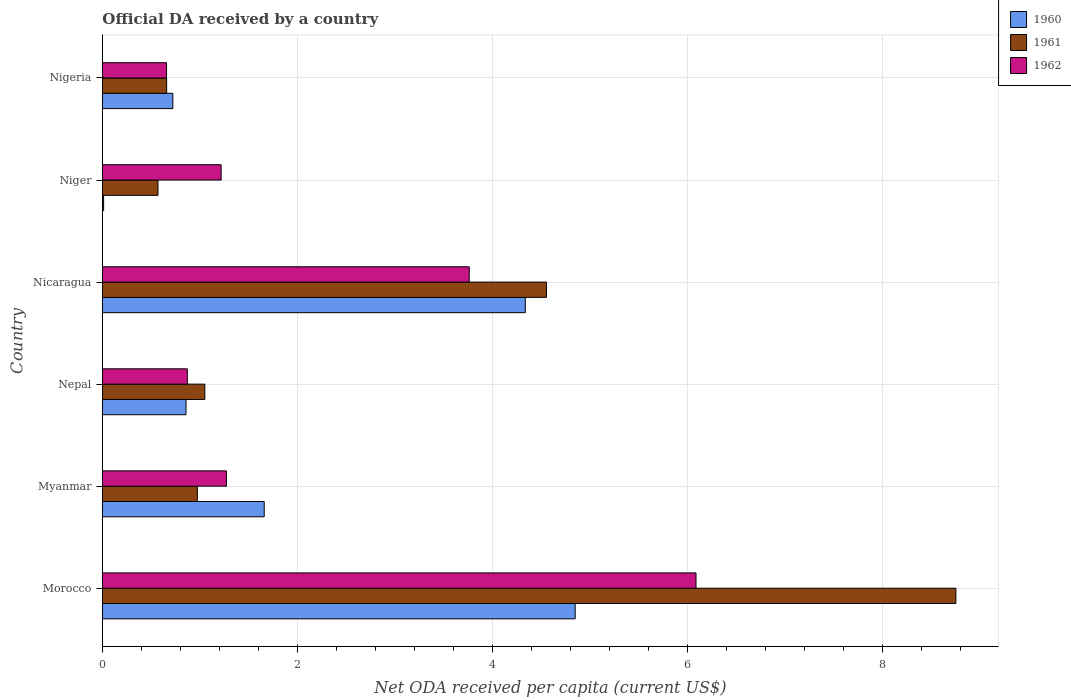How many groups of bars are there?
Keep it short and to the point. 6. What is the label of the 3rd group of bars from the top?
Your response must be concise. Nicaragua. What is the ODA received in in 1961 in Morocco?
Give a very brief answer. 8.76. Across all countries, what is the maximum ODA received in in 1961?
Ensure brevity in your answer.  8.76. Across all countries, what is the minimum ODA received in in 1962?
Give a very brief answer. 0.66. In which country was the ODA received in in 1960 maximum?
Offer a very short reply. Morocco. In which country was the ODA received in in 1960 minimum?
Ensure brevity in your answer.  Niger. What is the total ODA received in in 1961 in the graph?
Make the answer very short. 16.57. What is the difference between the ODA received in in 1962 in Morocco and that in Nicaragua?
Ensure brevity in your answer.  2.33. What is the difference between the ODA received in in 1960 in Myanmar and the ODA received in in 1962 in Nicaragua?
Your response must be concise. -2.1. What is the average ODA received in in 1960 per country?
Ensure brevity in your answer.  2.07. What is the difference between the ODA received in in 1961 and ODA received in in 1962 in Nigeria?
Your answer should be compact. 0. In how many countries, is the ODA received in in 1962 greater than 4 US$?
Keep it short and to the point. 1. What is the ratio of the ODA received in in 1960 in Nepal to that in Nicaragua?
Your answer should be very brief. 0.2. Is the ODA received in in 1962 in Morocco less than that in Myanmar?
Offer a terse response. No. Is the difference between the ODA received in in 1961 in Morocco and Nigeria greater than the difference between the ODA received in in 1962 in Morocco and Nigeria?
Offer a very short reply. Yes. What is the difference between the highest and the second highest ODA received in in 1961?
Your answer should be very brief. 4.2. What is the difference between the highest and the lowest ODA received in in 1961?
Offer a very short reply. 8.19. Is the sum of the ODA received in in 1961 in Myanmar and Nepal greater than the maximum ODA received in in 1962 across all countries?
Keep it short and to the point. No. Is it the case that in every country, the sum of the ODA received in in 1960 and ODA received in in 1962 is greater than the ODA received in in 1961?
Make the answer very short. Yes. How many bars are there?
Give a very brief answer. 18. How many countries are there in the graph?
Your answer should be compact. 6. What is the difference between two consecutive major ticks on the X-axis?
Provide a short and direct response. 2. Are the values on the major ticks of X-axis written in scientific E-notation?
Give a very brief answer. No. Where does the legend appear in the graph?
Offer a very short reply. Top right. How are the legend labels stacked?
Give a very brief answer. Vertical. What is the title of the graph?
Your response must be concise. Official DA received by a country. Does "1980" appear as one of the legend labels in the graph?
Offer a terse response. No. What is the label or title of the X-axis?
Your answer should be very brief. Net ODA received per capita (current US$). What is the label or title of the Y-axis?
Give a very brief answer. Country. What is the Net ODA received per capita (current US$) of 1960 in Morocco?
Offer a terse response. 4.85. What is the Net ODA received per capita (current US$) of 1961 in Morocco?
Make the answer very short. 8.76. What is the Net ODA received per capita (current US$) in 1962 in Morocco?
Give a very brief answer. 6.09. What is the Net ODA received per capita (current US$) in 1960 in Myanmar?
Give a very brief answer. 1.66. What is the Net ODA received per capita (current US$) in 1961 in Myanmar?
Keep it short and to the point. 0.97. What is the Net ODA received per capita (current US$) in 1962 in Myanmar?
Your response must be concise. 1.27. What is the Net ODA received per capita (current US$) of 1960 in Nepal?
Give a very brief answer. 0.86. What is the Net ODA received per capita (current US$) of 1961 in Nepal?
Give a very brief answer. 1.05. What is the Net ODA received per capita (current US$) of 1962 in Nepal?
Give a very brief answer. 0.87. What is the Net ODA received per capita (current US$) of 1960 in Nicaragua?
Offer a very short reply. 4.34. What is the Net ODA received per capita (current US$) of 1961 in Nicaragua?
Your response must be concise. 4.56. What is the Net ODA received per capita (current US$) of 1962 in Nicaragua?
Make the answer very short. 3.76. What is the Net ODA received per capita (current US$) in 1960 in Niger?
Your response must be concise. 0.01. What is the Net ODA received per capita (current US$) in 1961 in Niger?
Provide a succinct answer. 0.57. What is the Net ODA received per capita (current US$) in 1962 in Niger?
Ensure brevity in your answer.  1.22. What is the Net ODA received per capita (current US$) in 1960 in Nigeria?
Make the answer very short. 0.72. What is the Net ODA received per capita (current US$) of 1961 in Nigeria?
Your answer should be very brief. 0.66. What is the Net ODA received per capita (current US$) of 1962 in Nigeria?
Make the answer very short. 0.66. Across all countries, what is the maximum Net ODA received per capita (current US$) of 1960?
Your response must be concise. 4.85. Across all countries, what is the maximum Net ODA received per capita (current US$) of 1961?
Your answer should be compact. 8.76. Across all countries, what is the maximum Net ODA received per capita (current US$) of 1962?
Keep it short and to the point. 6.09. Across all countries, what is the minimum Net ODA received per capita (current US$) in 1960?
Keep it short and to the point. 0.01. Across all countries, what is the minimum Net ODA received per capita (current US$) of 1961?
Offer a very short reply. 0.57. Across all countries, what is the minimum Net ODA received per capita (current US$) in 1962?
Give a very brief answer. 0.66. What is the total Net ODA received per capita (current US$) of 1960 in the graph?
Your answer should be very brief. 12.44. What is the total Net ODA received per capita (current US$) in 1961 in the graph?
Ensure brevity in your answer.  16.57. What is the total Net ODA received per capita (current US$) of 1962 in the graph?
Provide a short and direct response. 13.87. What is the difference between the Net ODA received per capita (current US$) of 1960 in Morocco and that in Myanmar?
Keep it short and to the point. 3.19. What is the difference between the Net ODA received per capita (current US$) of 1961 in Morocco and that in Myanmar?
Keep it short and to the point. 7.78. What is the difference between the Net ODA received per capita (current US$) of 1962 in Morocco and that in Myanmar?
Your response must be concise. 4.82. What is the difference between the Net ODA received per capita (current US$) of 1960 in Morocco and that in Nepal?
Keep it short and to the point. 3.99. What is the difference between the Net ODA received per capita (current US$) of 1961 in Morocco and that in Nepal?
Offer a terse response. 7.71. What is the difference between the Net ODA received per capita (current US$) of 1962 in Morocco and that in Nepal?
Your answer should be very brief. 5.22. What is the difference between the Net ODA received per capita (current US$) of 1960 in Morocco and that in Nicaragua?
Offer a terse response. 0.51. What is the difference between the Net ODA received per capita (current US$) of 1961 in Morocco and that in Nicaragua?
Keep it short and to the point. 4.2. What is the difference between the Net ODA received per capita (current US$) in 1962 in Morocco and that in Nicaragua?
Make the answer very short. 2.33. What is the difference between the Net ODA received per capita (current US$) of 1960 in Morocco and that in Niger?
Make the answer very short. 4.84. What is the difference between the Net ODA received per capita (current US$) of 1961 in Morocco and that in Niger?
Offer a terse response. 8.19. What is the difference between the Net ODA received per capita (current US$) in 1962 in Morocco and that in Niger?
Your answer should be very brief. 4.87. What is the difference between the Net ODA received per capita (current US$) in 1960 in Morocco and that in Nigeria?
Ensure brevity in your answer.  4.13. What is the difference between the Net ODA received per capita (current US$) of 1961 in Morocco and that in Nigeria?
Your response must be concise. 8.1. What is the difference between the Net ODA received per capita (current US$) in 1962 in Morocco and that in Nigeria?
Provide a succinct answer. 5.43. What is the difference between the Net ODA received per capita (current US$) in 1960 in Myanmar and that in Nepal?
Ensure brevity in your answer.  0.8. What is the difference between the Net ODA received per capita (current US$) of 1961 in Myanmar and that in Nepal?
Offer a very short reply. -0.08. What is the difference between the Net ODA received per capita (current US$) of 1962 in Myanmar and that in Nepal?
Your response must be concise. 0.4. What is the difference between the Net ODA received per capita (current US$) of 1960 in Myanmar and that in Nicaragua?
Make the answer very short. -2.68. What is the difference between the Net ODA received per capita (current US$) in 1961 in Myanmar and that in Nicaragua?
Offer a very short reply. -3.58. What is the difference between the Net ODA received per capita (current US$) in 1962 in Myanmar and that in Nicaragua?
Ensure brevity in your answer.  -2.49. What is the difference between the Net ODA received per capita (current US$) in 1960 in Myanmar and that in Niger?
Provide a succinct answer. 1.65. What is the difference between the Net ODA received per capita (current US$) of 1961 in Myanmar and that in Niger?
Your answer should be compact. 0.4. What is the difference between the Net ODA received per capita (current US$) in 1962 in Myanmar and that in Niger?
Your answer should be very brief. 0.05. What is the difference between the Net ODA received per capita (current US$) in 1960 in Myanmar and that in Nigeria?
Make the answer very short. 0.94. What is the difference between the Net ODA received per capita (current US$) of 1961 in Myanmar and that in Nigeria?
Offer a very short reply. 0.31. What is the difference between the Net ODA received per capita (current US$) of 1962 in Myanmar and that in Nigeria?
Offer a terse response. 0.61. What is the difference between the Net ODA received per capita (current US$) of 1960 in Nepal and that in Nicaragua?
Make the answer very short. -3.48. What is the difference between the Net ODA received per capita (current US$) of 1961 in Nepal and that in Nicaragua?
Give a very brief answer. -3.51. What is the difference between the Net ODA received per capita (current US$) of 1962 in Nepal and that in Nicaragua?
Offer a very short reply. -2.89. What is the difference between the Net ODA received per capita (current US$) of 1960 in Nepal and that in Niger?
Your answer should be very brief. 0.85. What is the difference between the Net ODA received per capita (current US$) in 1961 in Nepal and that in Niger?
Give a very brief answer. 0.48. What is the difference between the Net ODA received per capita (current US$) of 1962 in Nepal and that in Niger?
Offer a terse response. -0.35. What is the difference between the Net ODA received per capita (current US$) in 1960 in Nepal and that in Nigeria?
Your response must be concise. 0.14. What is the difference between the Net ODA received per capita (current US$) in 1961 in Nepal and that in Nigeria?
Your answer should be compact. 0.39. What is the difference between the Net ODA received per capita (current US$) in 1962 in Nepal and that in Nigeria?
Give a very brief answer. 0.21. What is the difference between the Net ODA received per capita (current US$) in 1960 in Nicaragua and that in Niger?
Keep it short and to the point. 4.33. What is the difference between the Net ODA received per capita (current US$) of 1961 in Nicaragua and that in Niger?
Make the answer very short. 3.99. What is the difference between the Net ODA received per capita (current US$) in 1962 in Nicaragua and that in Niger?
Ensure brevity in your answer.  2.55. What is the difference between the Net ODA received per capita (current US$) of 1960 in Nicaragua and that in Nigeria?
Your answer should be compact. 3.62. What is the difference between the Net ODA received per capita (current US$) in 1961 in Nicaragua and that in Nigeria?
Give a very brief answer. 3.9. What is the difference between the Net ODA received per capita (current US$) of 1962 in Nicaragua and that in Nigeria?
Offer a very short reply. 3.11. What is the difference between the Net ODA received per capita (current US$) in 1960 in Niger and that in Nigeria?
Your answer should be compact. -0.71. What is the difference between the Net ODA received per capita (current US$) in 1961 in Niger and that in Nigeria?
Offer a very short reply. -0.09. What is the difference between the Net ODA received per capita (current US$) in 1962 in Niger and that in Nigeria?
Your answer should be compact. 0.56. What is the difference between the Net ODA received per capita (current US$) of 1960 in Morocco and the Net ODA received per capita (current US$) of 1961 in Myanmar?
Offer a terse response. 3.88. What is the difference between the Net ODA received per capita (current US$) of 1960 in Morocco and the Net ODA received per capita (current US$) of 1962 in Myanmar?
Offer a terse response. 3.58. What is the difference between the Net ODA received per capita (current US$) of 1961 in Morocco and the Net ODA received per capita (current US$) of 1962 in Myanmar?
Offer a very short reply. 7.48. What is the difference between the Net ODA received per capita (current US$) in 1960 in Morocco and the Net ODA received per capita (current US$) in 1961 in Nepal?
Provide a succinct answer. 3.8. What is the difference between the Net ODA received per capita (current US$) in 1960 in Morocco and the Net ODA received per capita (current US$) in 1962 in Nepal?
Offer a very short reply. 3.98. What is the difference between the Net ODA received per capita (current US$) of 1961 in Morocco and the Net ODA received per capita (current US$) of 1962 in Nepal?
Give a very brief answer. 7.89. What is the difference between the Net ODA received per capita (current US$) of 1960 in Morocco and the Net ODA received per capita (current US$) of 1961 in Nicaragua?
Your answer should be very brief. 0.29. What is the difference between the Net ODA received per capita (current US$) of 1960 in Morocco and the Net ODA received per capita (current US$) of 1962 in Nicaragua?
Your answer should be compact. 1.09. What is the difference between the Net ODA received per capita (current US$) of 1961 in Morocco and the Net ODA received per capita (current US$) of 1962 in Nicaragua?
Make the answer very short. 4.99. What is the difference between the Net ODA received per capita (current US$) of 1960 in Morocco and the Net ODA received per capita (current US$) of 1961 in Niger?
Give a very brief answer. 4.28. What is the difference between the Net ODA received per capita (current US$) of 1960 in Morocco and the Net ODA received per capita (current US$) of 1962 in Niger?
Provide a short and direct response. 3.63. What is the difference between the Net ODA received per capita (current US$) of 1961 in Morocco and the Net ODA received per capita (current US$) of 1962 in Niger?
Your answer should be very brief. 7.54. What is the difference between the Net ODA received per capita (current US$) in 1960 in Morocco and the Net ODA received per capita (current US$) in 1961 in Nigeria?
Provide a short and direct response. 4.19. What is the difference between the Net ODA received per capita (current US$) of 1960 in Morocco and the Net ODA received per capita (current US$) of 1962 in Nigeria?
Your response must be concise. 4.19. What is the difference between the Net ODA received per capita (current US$) of 1961 in Morocco and the Net ODA received per capita (current US$) of 1962 in Nigeria?
Your answer should be compact. 8.1. What is the difference between the Net ODA received per capita (current US$) in 1960 in Myanmar and the Net ODA received per capita (current US$) in 1961 in Nepal?
Your answer should be very brief. 0.61. What is the difference between the Net ODA received per capita (current US$) in 1960 in Myanmar and the Net ODA received per capita (current US$) in 1962 in Nepal?
Provide a short and direct response. 0.79. What is the difference between the Net ODA received per capita (current US$) in 1961 in Myanmar and the Net ODA received per capita (current US$) in 1962 in Nepal?
Ensure brevity in your answer.  0.1. What is the difference between the Net ODA received per capita (current US$) of 1960 in Myanmar and the Net ODA received per capita (current US$) of 1961 in Nicaragua?
Your answer should be compact. -2.9. What is the difference between the Net ODA received per capita (current US$) of 1960 in Myanmar and the Net ODA received per capita (current US$) of 1962 in Nicaragua?
Offer a very short reply. -2.1. What is the difference between the Net ODA received per capita (current US$) in 1961 in Myanmar and the Net ODA received per capita (current US$) in 1962 in Nicaragua?
Your answer should be compact. -2.79. What is the difference between the Net ODA received per capita (current US$) in 1960 in Myanmar and the Net ODA received per capita (current US$) in 1961 in Niger?
Give a very brief answer. 1.09. What is the difference between the Net ODA received per capita (current US$) of 1960 in Myanmar and the Net ODA received per capita (current US$) of 1962 in Niger?
Your answer should be very brief. 0.44. What is the difference between the Net ODA received per capita (current US$) in 1961 in Myanmar and the Net ODA received per capita (current US$) in 1962 in Niger?
Offer a terse response. -0.24. What is the difference between the Net ODA received per capita (current US$) of 1961 in Myanmar and the Net ODA received per capita (current US$) of 1962 in Nigeria?
Offer a very short reply. 0.32. What is the difference between the Net ODA received per capita (current US$) in 1960 in Nepal and the Net ODA received per capita (current US$) in 1961 in Nicaragua?
Give a very brief answer. -3.7. What is the difference between the Net ODA received per capita (current US$) in 1960 in Nepal and the Net ODA received per capita (current US$) in 1962 in Nicaragua?
Provide a short and direct response. -2.91. What is the difference between the Net ODA received per capita (current US$) in 1961 in Nepal and the Net ODA received per capita (current US$) in 1962 in Nicaragua?
Ensure brevity in your answer.  -2.71. What is the difference between the Net ODA received per capita (current US$) in 1960 in Nepal and the Net ODA received per capita (current US$) in 1961 in Niger?
Make the answer very short. 0.29. What is the difference between the Net ODA received per capita (current US$) in 1960 in Nepal and the Net ODA received per capita (current US$) in 1962 in Niger?
Keep it short and to the point. -0.36. What is the difference between the Net ODA received per capita (current US$) in 1961 in Nepal and the Net ODA received per capita (current US$) in 1962 in Niger?
Give a very brief answer. -0.17. What is the difference between the Net ODA received per capita (current US$) in 1960 in Nepal and the Net ODA received per capita (current US$) in 1961 in Nigeria?
Give a very brief answer. 0.2. What is the difference between the Net ODA received per capita (current US$) in 1960 in Nepal and the Net ODA received per capita (current US$) in 1962 in Nigeria?
Give a very brief answer. 0.2. What is the difference between the Net ODA received per capita (current US$) of 1961 in Nepal and the Net ODA received per capita (current US$) of 1962 in Nigeria?
Your answer should be compact. 0.39. What is the difference between the Net ODA received per capita (current US$) in 1960 in Nicaragua and the Net ODA received per capita (current US$) in 1961 in Niger?
Offer a terse response. 3.77. What is the difference between the Net ODA received per capita (current US$) of 1960 in Nicaragua and the Net ODA received per capita (current US$) of 1962 in Niger?
Your answer should be very brief. 3.12. What is the difference between the Net ODA received per capita (current US$) of 1961 in Nicaragua and the Net ODA received per capita (current US$) of 1962 in Niger?
Provide a succinct answer. 3.34. What is the difference between the Net ODA received per capita (current US$) in 1960 in Nicaragua and the Net ODA received per capita (current US$) in 1961 in Nigeria?
Keep it short and to the point. 3.68. What is the difference between the Net ODA received per capita (current US$) of 1960 in Nicaragua and the Net ODA received per capita (current US$) of 1962 in Nigeria?
Offer a terse response. 3.68. What is the difference between the Net ODA received per capita (current US$) in 1961 in Nicaragua and the Net ODA received per capita (current US$) in 1962 in Nigeria?
Offer a very short reply. 3.9. What is the difference between the Net ODA received per capita (current US$) in 1960 in Niger and the Net ODA received per capita (current US$) in 1961 in Nigeria?
Ensure brevity in your answer.  -0.65. What is the difference between the Net ODA received per capita (current US$) of 1960 in Niger and the Net ODA received per capita (current US$) of 1962 in Nigeria?
Offer a terse response. -0.65. What is the difference between the Net ODA received per capita (current US$) in 1961 in Niger and the Net ODA received per capita (current US$) in 1962 in Nigeria?
Provide a succinct answer. -0.09. What is the average Net ODA received per capita (current US$) in 1960 per country?
Make the answer very short. 2.07. What is the average Net ODA received per capita (current US$) of 1961 per country?
Your response must be concise. 2.76. What is the average Net ODA received per capita (current US$) in 1962 per country?
Your response must be concise. 2.31. What is the difference between the Net ODA received per capita (current US$) of 1960 and Net ODA received per capita (current US$) of 1961 in Morocco?
Your answer should be very brief. -3.91. What is the difference between the Net ODA received per capita (current US$) in 1960 and Net ODA received per capita (current US$) in 1962 in Morocco?
Provide a short and direct response. -1.24. What is the difference between the Net ODA received per capita (current US$) in 1961 and Net ODA received per capita (current US$) in 1962 in Morocco?
Keep it short and to the point. 2.67. What is the difference between the Net ODA received per capita (current US$) of 1960 and Net ODA received per capita (current US$) of 1961 in Myanmar?
Provide a succinct answer. 0.69. What is the difference between the Net ODA received per capita (current US$) of 1960 and Net ODA received per capita (current US$) of 1962 in Myanmar?
Your response must be concise. 0.39. What is the difference between the Net ODA received per capita (current US$) in 1961 and Net ODA received per capita (current US$) in 1962 in Myanmar?
Provide a succinct answer. -0.3. What is the difference between the Net ODA received per capita (current US$) in 1960 and Net ODA received per capita (current US$) in 1961 in Nepal?
Make the answer very short. -0.19. What is the difference between the Net ODA received per capita (current US$) of 1960 and Net ODA received per capita (current US$) of 1962 in Nepal?
Your answer should be compact. -0.01. What is the difference between the Net ODA received per capita (current US$) of 1961 and Net ODA received per capita (current US$) of 1962 in Nepal?
Give a very brief answer. 0.18. What is the difference between the Net ODA received per capita (current US$) of 1960 and Net ODA received per capita (current US$) of 1961 in Nicaragua?
Your answer should be compact. -0.22. What is the difference between the Net ODA received per capita (current US$) in 1960 and Net ODA received per capita (current US$) in 1962 in Nicaragua?
Make the answer very short. 0.58. What is the difference between the Net ODA received per capita (current US$) in 1961 and Net ODA received per capita (current US$) in 1962 in Nicaragua?
Make the answer very short. 0.79. What is the difference between the Net ODA received per capita (current US$) of 1960 and Net ODA received per capita (current US$) of 1961 in Niger?
Your response must be concise. -0.56. What is the difference between the Net ODA received per capita (current US$) of 1960 and Net ODA received per capita (current US$) of 1962 in Niger?
Your answer should be very brief. -1.21. What is the difference between the Net ODA received per capita (current US$) in 1961 and Net ODA received per capita (current US$) in 1962 in Niger?
Provide a succinct answer. -0.65. What is the difference between the Net ODA received per capita (current US$) in 1960 and Net ODA received per capita (current US$) in 1961 in Nigeria?
Provide a succinct answer. 0.06. What is the difference between the Net ODA received per capita (current US$) in 1960 and Net ODA received per capita (current US$) in 1962 in Nigeria?
Provide a succinct answer. 0.06. What is the difference between the Net ODA received per capita (current US$) of 1961 and Net ODA received per capita (current US$) of 1962 in Nigeria?
Your answer should be very brief. 0. What is the ratio of the Net ODA received per capita (current US$) of 1960 in Morocco to that in Myanmar?
Offer a very short reply. 2.92. What is the ratio of the Net ODA received per capita (current US$) of 1961 in Morocco to that in Myanmar?
Provide a short and direct response. 9. What is the ratio of the Net ODA received per capita (current US$) of 1962 in Morocco to that in Myanmar?
Provide a succinct answer. 4.79. What is the ratio of the Net ODA received per capita (current US$) in 1960 in Morocco to that in Nepal?
Your answer should be compact. 5.66. What is the ratio of the Net ODA received per capita (current US$) in 1961 in Morocco to that in Nepal?
Your answer should be compact. 8.34. What is the ratio of the Net ODA received per capita (current US$) in 1962 in Morocco to that in Nepal?
Your answer should be very brief. 6.99. What is the ratio of the Net ODA received per capita (current US$) of 1960 in Morocco to that in Nicaragua?
Provide a short and direct response. 1.12. What is the ratio of the Net ODA received per capita (current US$) of 1961 in Morocco to that in Nicaragua?
Keep it short and to the point. 1.92. What is the ratio of the Net ODA received per capita (current US$) of 1962 in Morocco to that in Nicaragua?
Make the answer very short. 1.62. What is the ratio of the Net ODA received per capita (current US$) in 1960 in Morocco to that in Niger?
Offer a terse response. 411.71. What is the ratio of the Net ODA received per capita (current US$) of 1961 in Morocco to that in Niger?
Provide a short and direct response. 15.37. What is the ratio of the Net ODA received per capita (current US$) in 1962 in Morocco to that in Niger?
Provide a succinct answer. 5. What is the ratio of the Net ODA received per capita (current US$) of 1960 in Morocco to that in Nigeria?
Keep it short and to the point. 6.72. What is the ratio of the Net ODA received per capita (current US$) in 1961 in Morocco to that in Nigeria?
Your response must be concise. 13.3. What is the ratio of the Net ODA received per capita (current US$) in 1962 in Morocco to that in Nigeria?
Offer a terse response. 9.26. What is the ratio of the Net ODA received per capita (current US$) in 1960 in Myanmar to that in Nepal?
Provide a short and direct response. 1.94. What is the ratio of the Net ODA received per capita (current US$) of 1961 in Myanmar to that in Nepal?
Keep it short and to the point. 0.93. What is the ratio of the Net ODA received per capita (current US$) of 1962 in Myanmar to that in Nepal?
Your answer should be very brief. 1.46. What is the ratio of the Net ODA received per capita (current US$) of 1960 in Myanmar to that in Nicaragua?
Provide a succinct answer. 0.38. What is the ratio of the Net ODA received per capita (current US$) of 1961 in Myanmar to that in Nicaragua?
Your answer should be very brief. 0.21. What is the ratio of the Net ODA received per capita (current US$) in 1962 in Myanmar to that in Nicaragua?
Your answer should be compact. 0.34. What is the ratio of the Net ODA received per capita (current US$) in 1960 in Myanmar to that in Niger?
Ensure brevity in your answer.  140.87. What is the ratio of the Net ODA received per capita (current US$) in 1961 in Myanmar to that in Niger?
Provide a short and direct response. 1.71. What is the ratio of the Net ODA received per capita (current US$) of 1962 in Myanmar to that in Niger?
Provide a succinct answer. 1.04. What is the ratio of the Net ODA received per capita (current US$) of 1960 in Myanmar to that in Nigeria?
Provide a succinct answer. 2.3. What is the ratio of the Net ODA received per capita (current US$) of 1961 in Myanmar to that in Nigeria?
Provide a short and direct response. 1.48. What is the ratio of the Net ODA received per capita (current US$) of 1962 in Myanmar to that in Nigeria?
Ensure brevity in your answer.  1.94. What is the ratio of the Net ODA received per capita (current US$) of 1960 in Nepal to that in Nicaragua?
Ensure brevity in your answer.  0.2. What is the ratio of the Net ODA received per capita (current US$) of 1961 in Nepal to that in Nicaragua?
Offer a very short reply. 0.23. What is the ratio of the Net ODA received per capita (current US$) in 1962 in Nepal to that in Nicaragua?
Provide a succinct answer. 0.23. What is the ratio of the Net ODA received per capita (current US$) of 1960 in Nepal to that in Niger?
Your answer should be compact. 72.75. What is the ratio of the Net ODA received per capita (current US$) of 1961 in Nepal to that in Niger?
Your answer should be very brief. 1.84. What is the ratio of the Net ODA received per capita (current US$) of 1962 in Nepal to that in Niger?
Give a very brief answer. 0.72. What is the ratio of the Net ODA received per capita (current US$) in 1960 in Nepal to that in Nigeria?
Offer a very short reply. 1.19. What is the ratio of the Net ODA received per capita (current US$) in 1961 in Nepal to that in Nigeria?
Make the answer very short. 1.59. What is the ratio of the Net ODA received per capita (current US$) in 1962 in Nepal to that in Nigeria?
Provide a short and direct response. 1.32. What is the ratio of the Net ODA received per capita (current US$) in 1960 in Nicaragua to that in Niger?
Make the answer very short. 368.28. What is the ratio of the Net ODA received per capita (current US$) of 1961 in Nicaragua to that in Niger?
Offer a very short reply. 8. What is the ratio of the Net ODA received per capita (current US$) of 1962 in Nicaragua to that in Niger?
Give a very brief answer. 3.09. What is the ratio of the Net ODA received per capita (current US$) of 1960 in Nicaragua to that in Nigeria?
Offer a terse response. 6.01. What is the ratio of the Net ODA received per capita (current US$) of 1961 in Nicaragua to that in Nigeria?
Make the answer very short. 6.92. What is the ratio of the Net ODA received per capita (current US$) in 1962 in Nicaragua to that in Nigeria?
Offer a very short reply. 5.72. What is the ratio of the Net ODA received per capita (current US$) in 1960 in Niger to that in Nigeria?
Make the answer very short. 0.02. What is the ratio of the Net ODA received per capita (current US$) of 1961 in Niger to that in Nigeria?
Offer a very short reply. 0.86. What is the ratio of the Net ODA received per capita (current US$) of 1962 in Niger to that in Nigeria?
Offer a terse response. 1.85. What is the difference between the highest and the second highest Net ODA received per capita (current US$) in 1960?
Make the answer very short. 0.51. What is the difference between the highest and the second highest Net ODA received per capita (current US$) of 1961?
Your answer should be very brief. 4.2. What is the difference between the highest and the second highest Net ODA received per capita (current US$) of 1962?
Offer a very short reply. 2.33. What is the difference between the highest and the lowest Net ODA received per capita (current US$) in 1960?
Offer a terse response. 4.84. What is the difference between the highest and the lowest Net ODA received per capita (current US$) in 1961?
Offer a terse response. 8.19. What is the difference between the highest and the lowest Net ODA received per capita (current US$) of 1962?
Give a very brief answer. 5.43. 